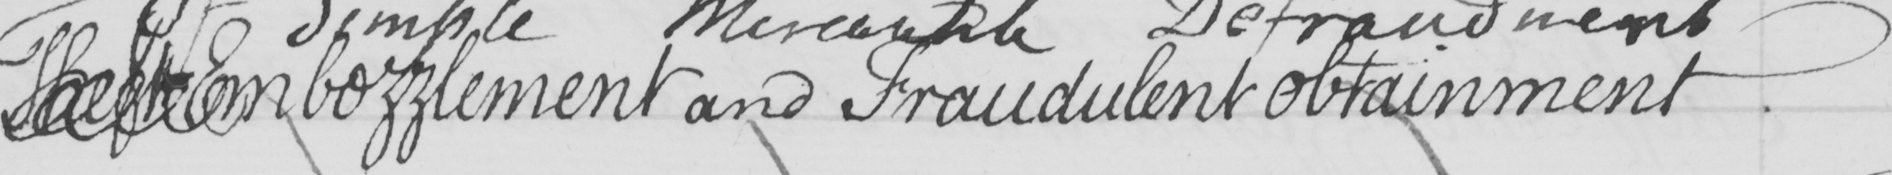What does this handwritten line say? Theft Embezzlement and Fraudulent obtainment 